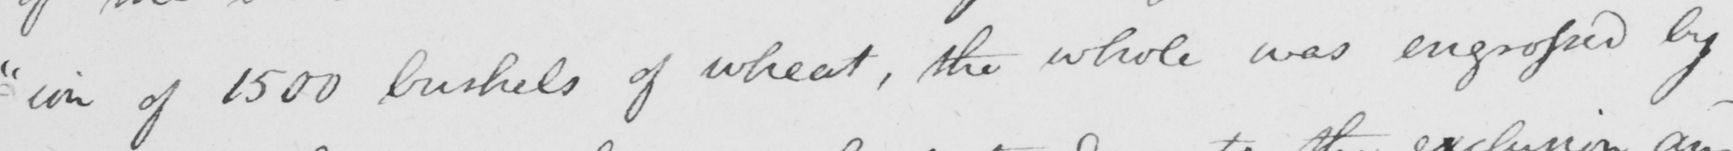Please transcribe the handwritten text in this image. - " ion of 1500 bushels of wheat , the whole was engrossed by 